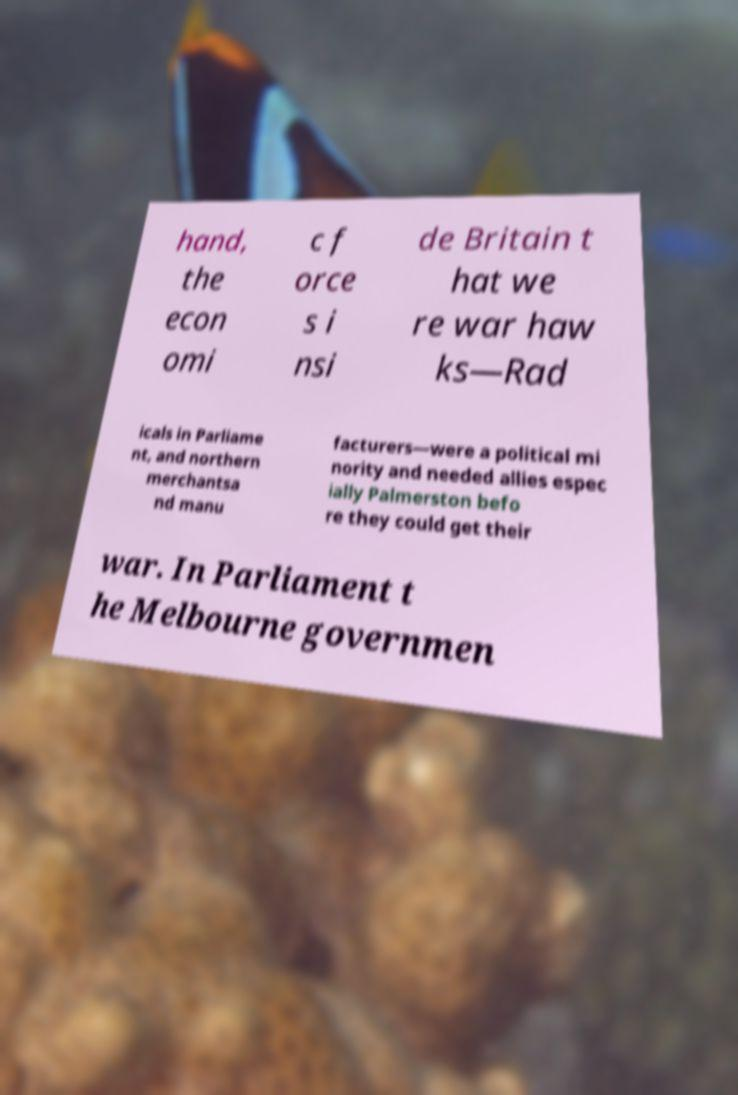I need the written content from this picture converted into text. Can you do that? hand, the econ omi c f orce s i nsi de Britain t hat we re war haw ks—Rad icals in Parliame nt, and northern merchantsa nd manu facturers—were a political mi nority and needed allies espec ially Palmerston befo re they could get their war. In Parliament t he Melbourne governmen 